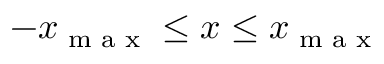<formula> <loc_0><loc_0><loc_500><loc_500>- x _ { \max } \leq x \leq x _ { \max }</formula> 